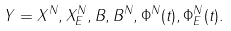Convert formula to latex. <formula><loc_0><loc_0><loc_500><loc_500>Y = X ^ { N } , X ^ { N } _ { E } , B , B ^ { N } , \Phi ^ { N } ( t ) , \Phi ^ { N } _ { E } ( t ) .</formula> 